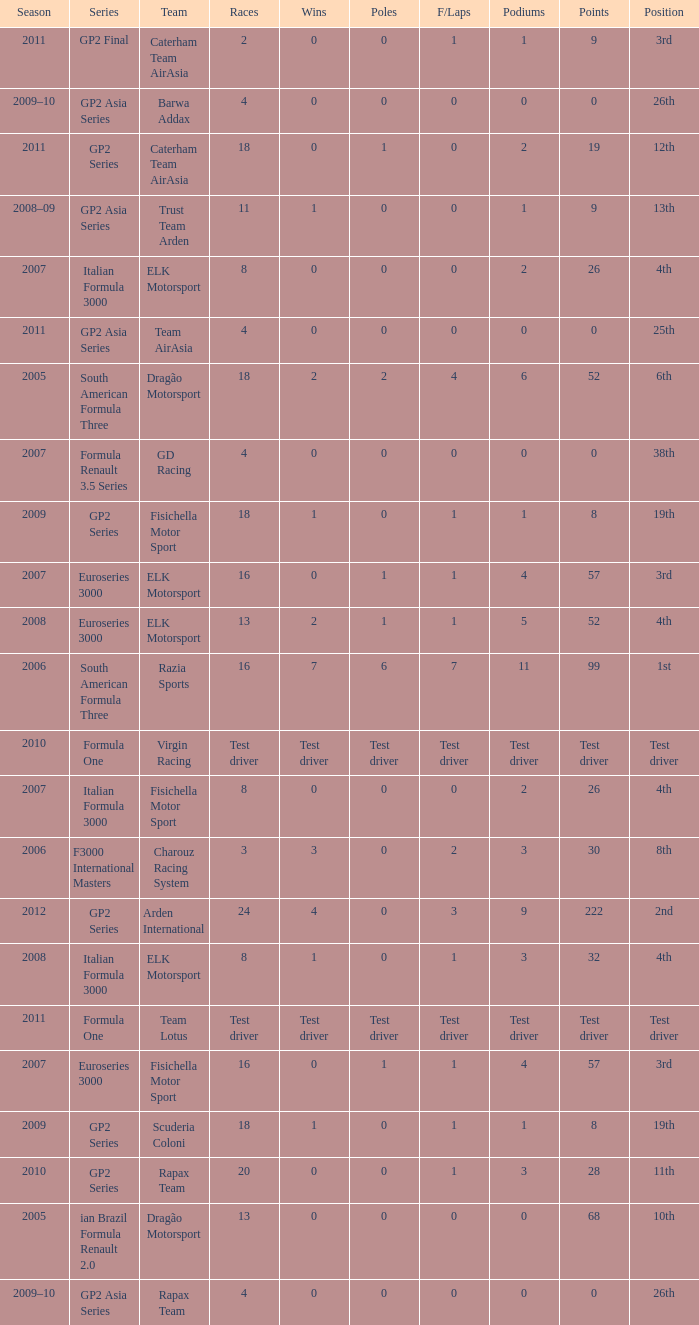What were the points in the year when his Podiums were 5? 52.0. 